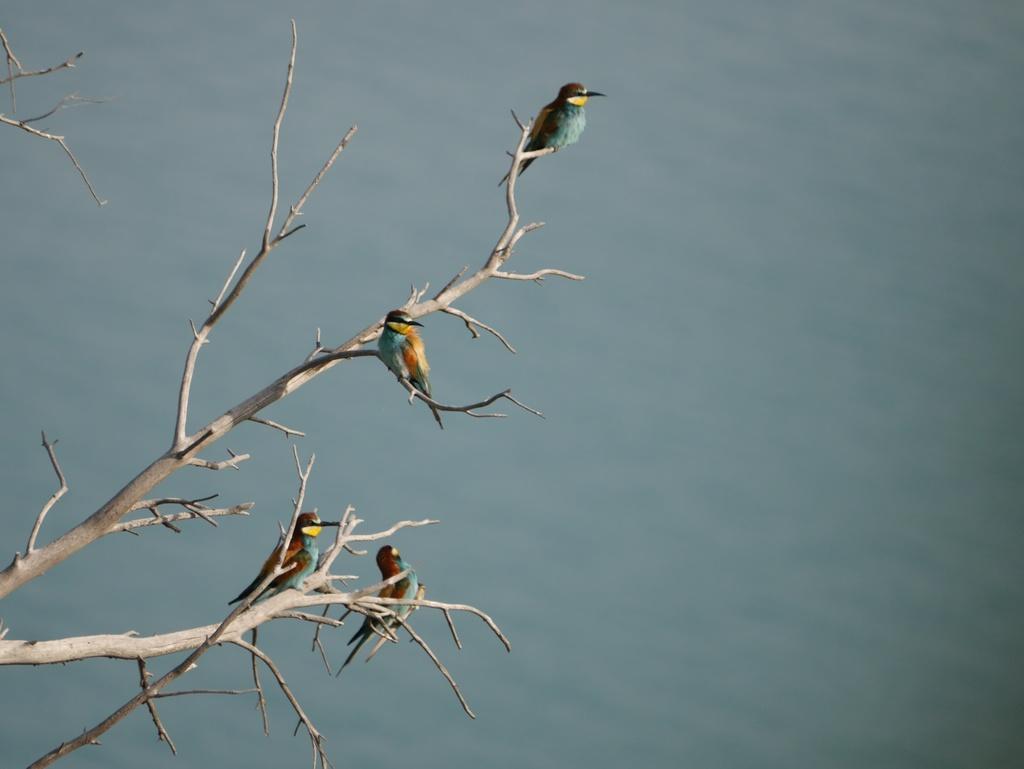Could you give a brief overview of what you see in this image? In this picture I can see four birds who are standing on this tree branch. In the background it might be the water or sky. 